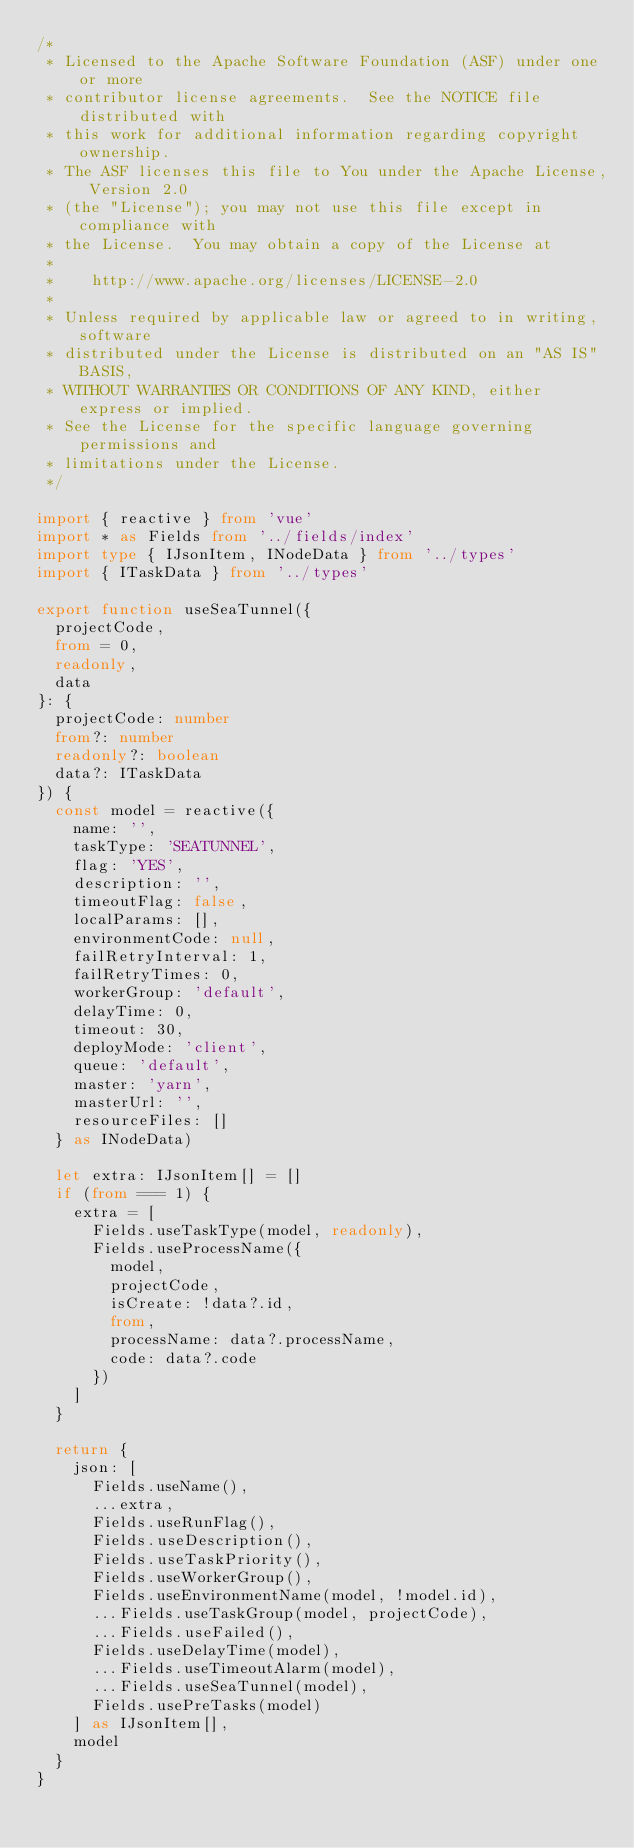<code> <loc_0><loc_0><loc_500><loc_500><_TypeScript_>/*
 * Licensed to the Apache Software Foundation (ASF) under one or more
 * contributor license agreements.  See the NOTICE file distributed with
 * this work for additional information regarding copyright ownership.
 * The ASF licenses this file to You under the Apache License, Version 2.0
 * (the "License"); you may not use this file except in compliance with
 * the License.  You may obtain a copy of the License at
 *
 *    http://www.apache.org/licenses/LICENSE-2.0
 *
 * Unless required by applicable law or agreed to in writing, software
 * distributed under the License is distributed on an "AS IS" BASIS,
 * WITHOUT WARRANTIES OR CONDITIONS OF ANY KIND, either express or implied.
 * See the License for the specific language governing permissions and
 * limitations under the License.
 */

import { reactive } from 'vue'
import * as Fields from '../fields/index'
import type { IJsonItem, INodeData } from '../types'
import { ITaskData } from '../types'

export function useSeaTunnel({
  projectCode,
  from = 0,
  readonly,
  data
}: {
  projectCode: number
  from?: number
  readonly?: boolean
  data?: ITaskData
}) {
  const model = reactive({
    name: '',
    taskType: 'SEATUNNEL',
    flag: 'YES',
    description: '',
    timeoutFlag: false,
    localParams: [],
    environmentCode: null,
    failRetryInterval: 1,
    failRetryTimes: 0,
    workerGroup: 'default',
    delayTime: 0,
    timeout: 30,
    deployMode: 'client',
    queue: 'default',
    master: 'yarn',
    masterUrl: '',
    resourceFiles: []
  } as INodeData)

  let extra: IJsonItem[] = []
  if (from === 1) {
    extra = [
      Fields.useTaskType(model, readonly),
      Fields.useProcessName({
        model,
        projectCode,
        isCreate: !data?.id,
        from,
        processName: data?.processName,
        code: data?.code
      })
    ]
  }

  return {
    json: [
      Fields.useName(),
      ...extra,
      Fields.useRunFlag(),
      Fields.useDescription(),
      Fields.useTaskPriority(),
      Fields.useWorkerGroup(),
      Fields.useEnvironmentName(model, !model.id),
      ...Fields.useTaskGroup(model, projectCode),
      ...Fields.useFailed(),
      Fields.useDelayTime(model),
      ...Fields.useTimeoutAlarm(model),
      ...Fields.useSeaTunnel(model),
      Fields.usePreTasks(model)
    ] as IJsonItem[],
    model
  }
}
</code> 